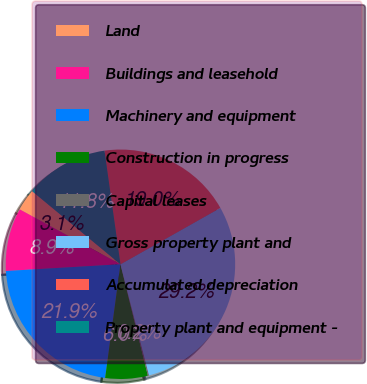Convert chart to OTSL. <chart><loc_0><loc_0><loc_500><loc_500><pie_chart><fcel>Land<fcel>Buildings and leasehold<fcel>Machinery and equipment<fcel>Construction in progress<fcel>Capital leases<fcel>Gross property plant and<fcel>Accumulated depreciation<fcel>Property plant and equipment -<nl><fcel>3.07%<fcel>8.87%<fcel>21.94%<fcel>5.97%<fcel>0.17%<fcel>29.17%<fcel>19.04%<fcel>11.77%<nl></chart> 